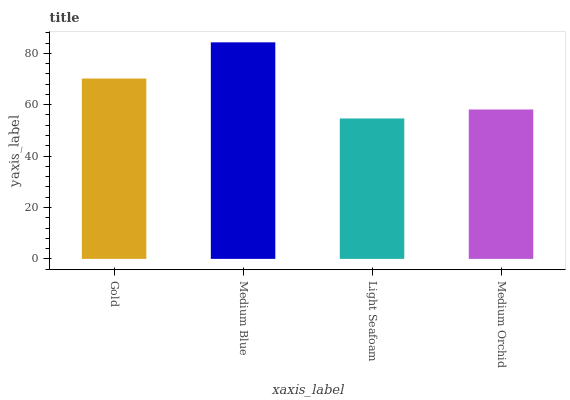Is Light Seafoam the minimum?
Answer yes or no. Yes. Is Medium Blue the maximum?
Answer yes or no. Yes. Is Medium Blue the minimum?
Answer yes or no. No. Is Light Seafoam the maximum?
Answer yes or no. No. Is Medium Blue greater than Light Seafoam?
Answer yes or no. Yes. Is Light Seafoam less than Medium Blue?
Answer yes or no. Yes. Is Light Seafoam greater than Medium Blue?
Answer yes or no. No. Is Medium Blue less than Light Seafoam?
Answer yes or no. No. Is Gold the high median?
Answer yes or no. Yes. Is Medium Orchid the low median?
Answer yes or no. Yes. Is Medium Blue the high median?
Answer yes or no. No. Is Gold the low median?
Answer yes or no. No. 